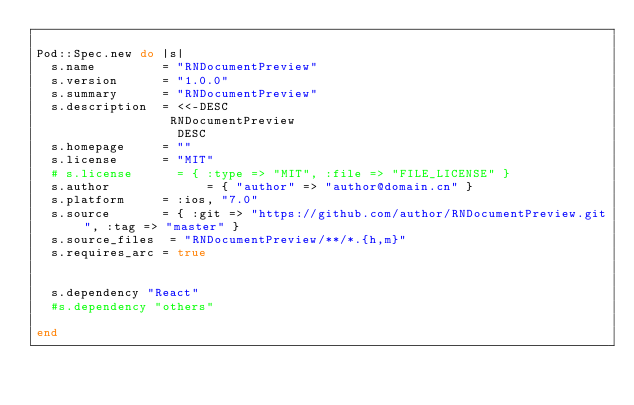<code> <loc_0><loc_0><loc_500><loc_500><_Ruby_>
Pod::Spec.new do |s|
  s.name         = "RNDocumentPreview"
  s.version      = "1.0.0"
  s.summary      = "RNDocumentPreview"
  s.description  = <<-DESC
                  RNDocumentPreview
                   DESC
  s.homepage     = ""
  s.license      = "MIT"
  # s.license      = { :type => "MIT", :file => "FILE_LICENSE" }
  s.author             = { "author" => "author@domain.cn" }
  s.platform     = :ios, "7.0"
  s.source       = { :git => "https://github.com/author/RNDocumentPreview.git", :tag => "master" }
  s.source_files  = "RNDocumentPreview/**/*.{h,m}"
  s.requires_arc = true


  s.dependency "React"
  #s.dependency "others"

end

  </code> 